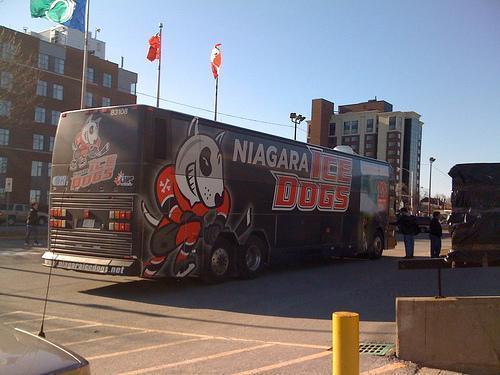How many people are visible?
Give a very brief answer. 3. How many cartoon dogs are visible on the bus?
Give a very brief answer. 2. How many flags are in the background?
Give a very brief answer. 3. 